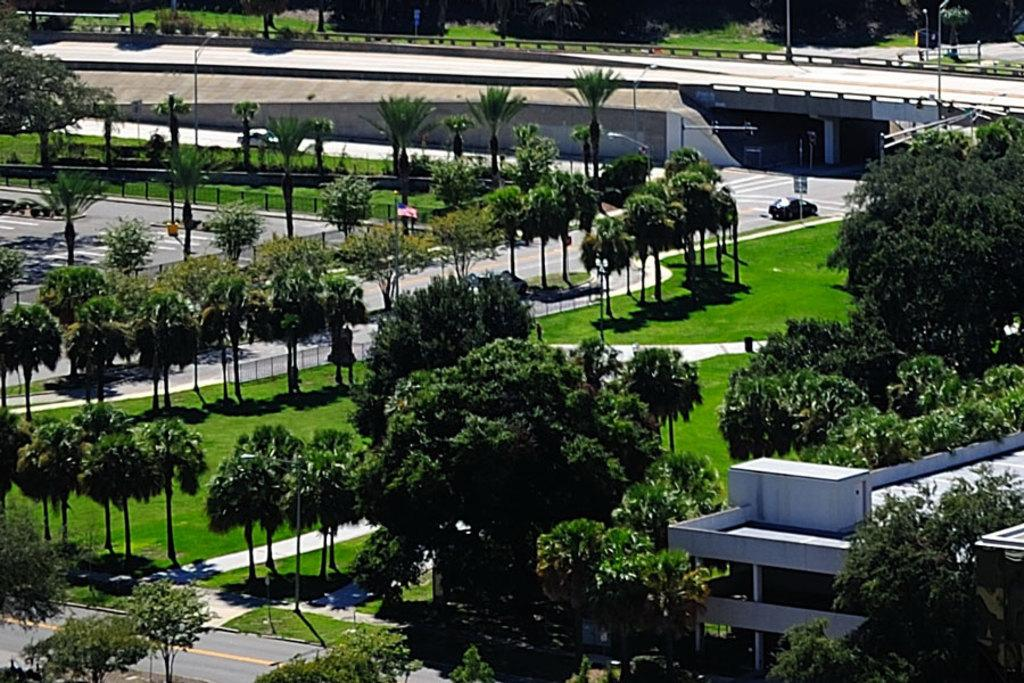What type of vegetation can be seen in the image? There are trees with green color in the image. What is the color of the building in the image? The building in the image has a white color. What can be seen in the background of the image? There are vehicles visible in the background of the image. What traffic control device is present in the image? There is a traffic signal in the image. What type of structure is present in the image that allows vehicles to pass over a body of water or obstacle? There is a bridge in the image. What type of farm animals can be seen grazing on the grass in the image? There are no farm animals or grass present in the image. What type of secretary can be seen working at a desk in the image? There is no secretary or desk present in the image. 